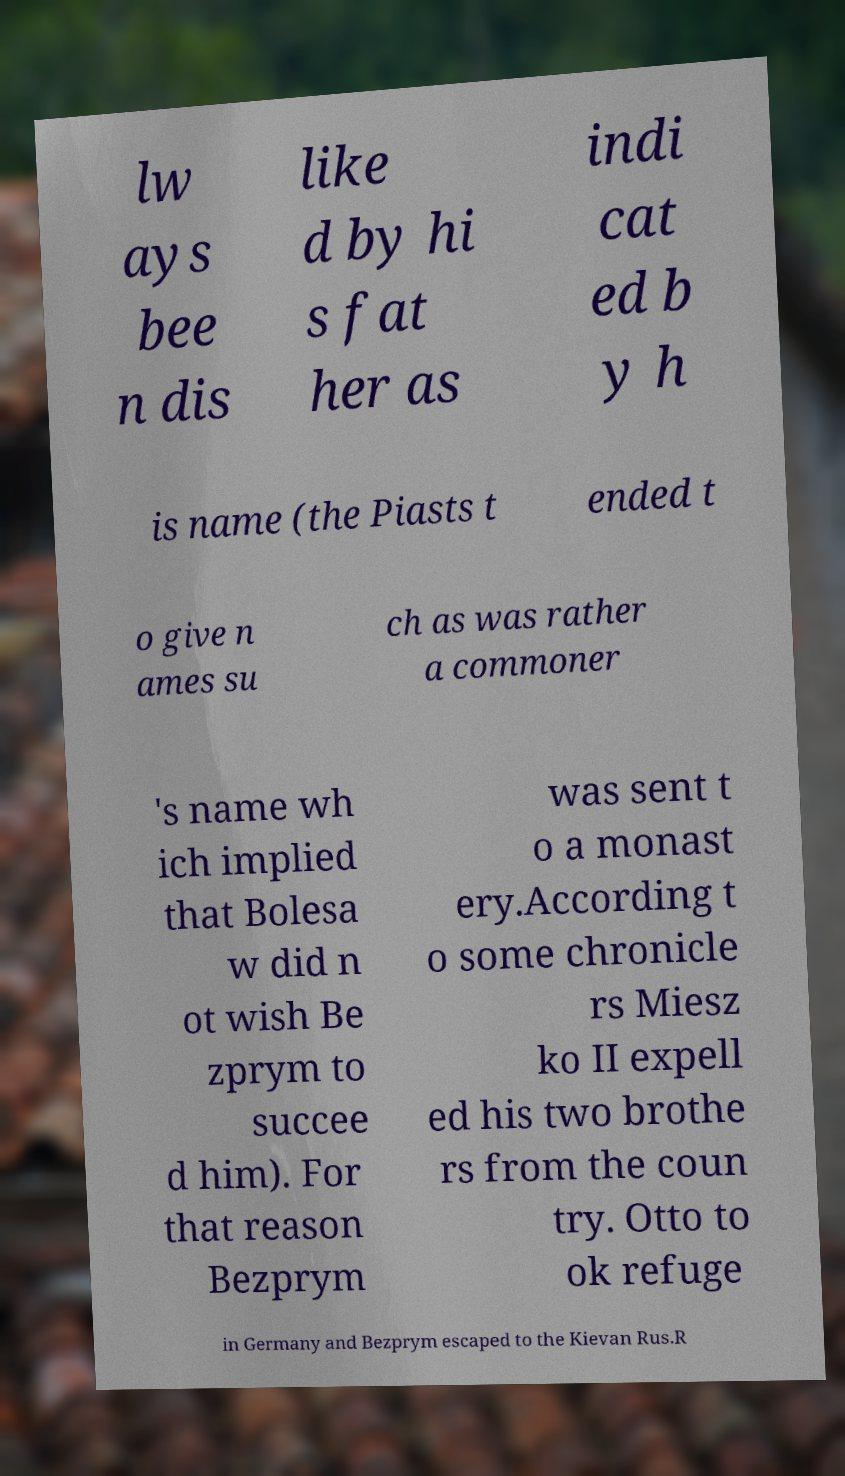I need the written content from this picture converted into text. Can you do that? lw ays bee n dis like d by hi s fat her as indi cat ed b y h is name (the Piasts t ended t o give n ames su ch as was rather a commoner 's name wh ich implied that Bolesa w did n ot wish Be zprym to succee d him). For that reason Bezprym was sent t o a monast ery.According t o some chronicle rs Miesz ko II expell ed his two brothe rs from the coun try. Otto to ok refuge in Germany and Bezprym escaped to the Kievan Rus.R 